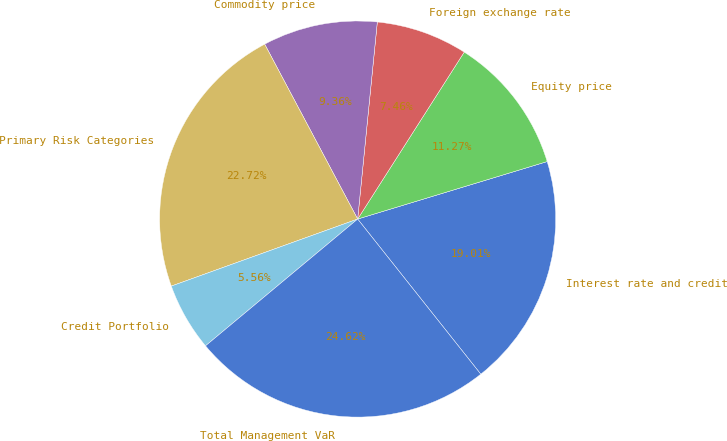Convert chart to OTSL. <chart><loc_0><loc_0><loc_500><loc_500><pie_chart><fcel>Interest rate and credit<fcel>Equity price<fcel>Foreign exchange rate<fcel>Commodity price<fcel>Primary Risk Categories<fcel>Credit Portfolio<fcel>Total Management VaR<nl><fcel>19.01%<fcel>11.27%<fcel>7.46%<fcel>9.36%<fcel>22.72%<fcel>5.56%<fcel>24.62%<nl></chart> 